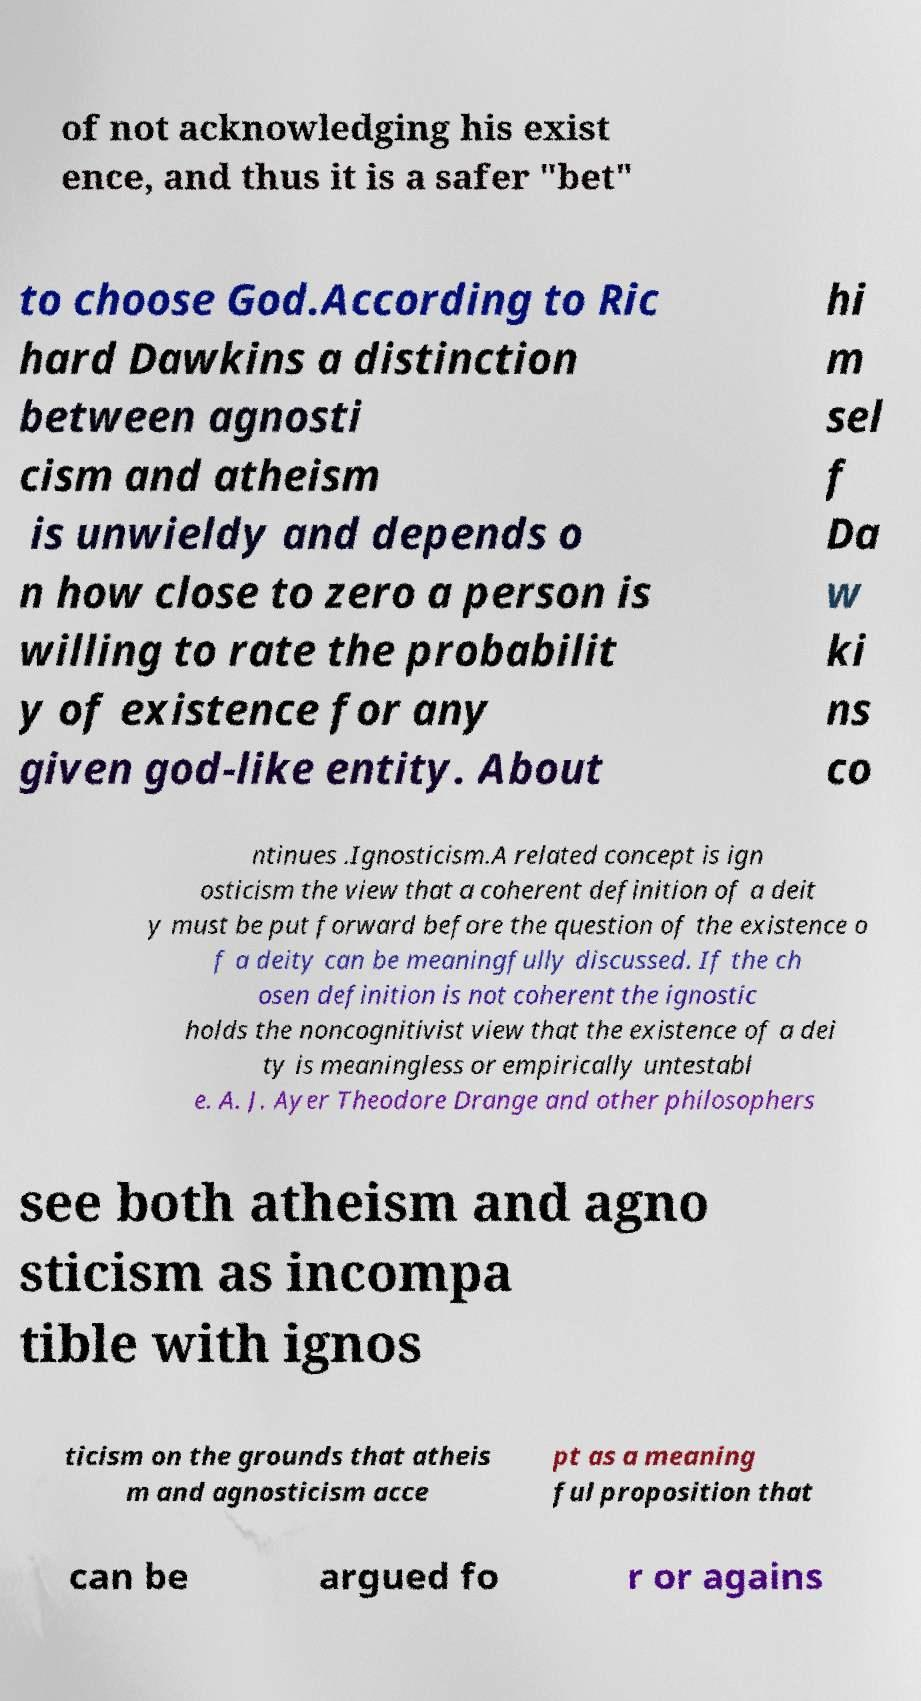Could you extract and type out the text from this image? of not acknowledging his exist ence, and thus it is a safer "bet" to choose God.According to Ric hard Dawkins a distinction between agnosti cism and atheism is unwieldy and depends o n how close to zero a person is willing to rate the probabilit y of existence for any given god-like entity. About hi m sel f Da w ki ns co ntinues .Ignosticism.A related concept is ign osticism the view that a coherent definition of a deit y must be put forward before the question of the existence o f a deity can be meaningfully discussed. If the ch osen definition is not coherent the ignostic holds the noncognitivist view that the existence of a dei ty is meaningless or empirically untestabl e. A. J. Ayer Theodore Drange and other philosophers see both atheism and agno sticism as incompa tible with ignos ticism on the grounds that atheis m and agnosticism acce pt as a meaning ful proposition that can be argued fo r or agains 